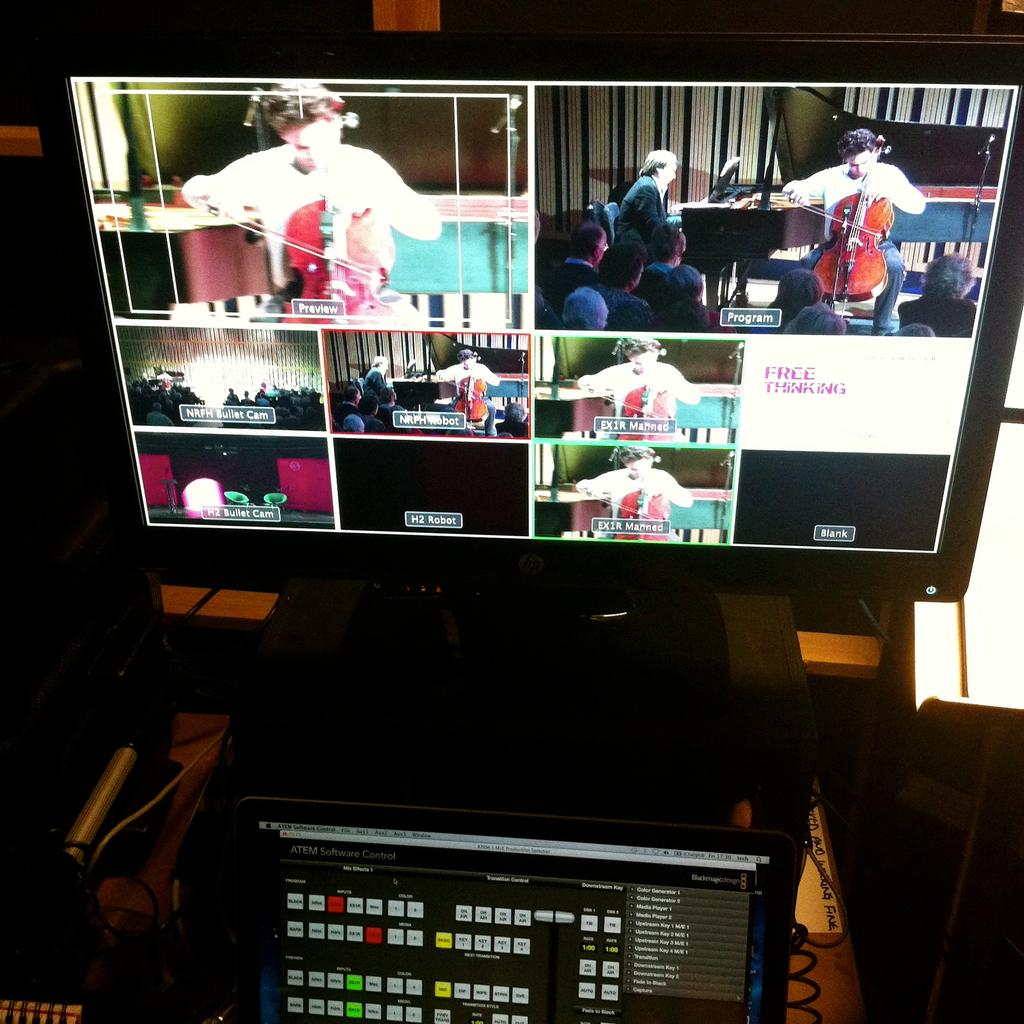<image>
Present a compact description of the photo's key features. A monitor shows an orchestra with one screen stating Free Thinking 